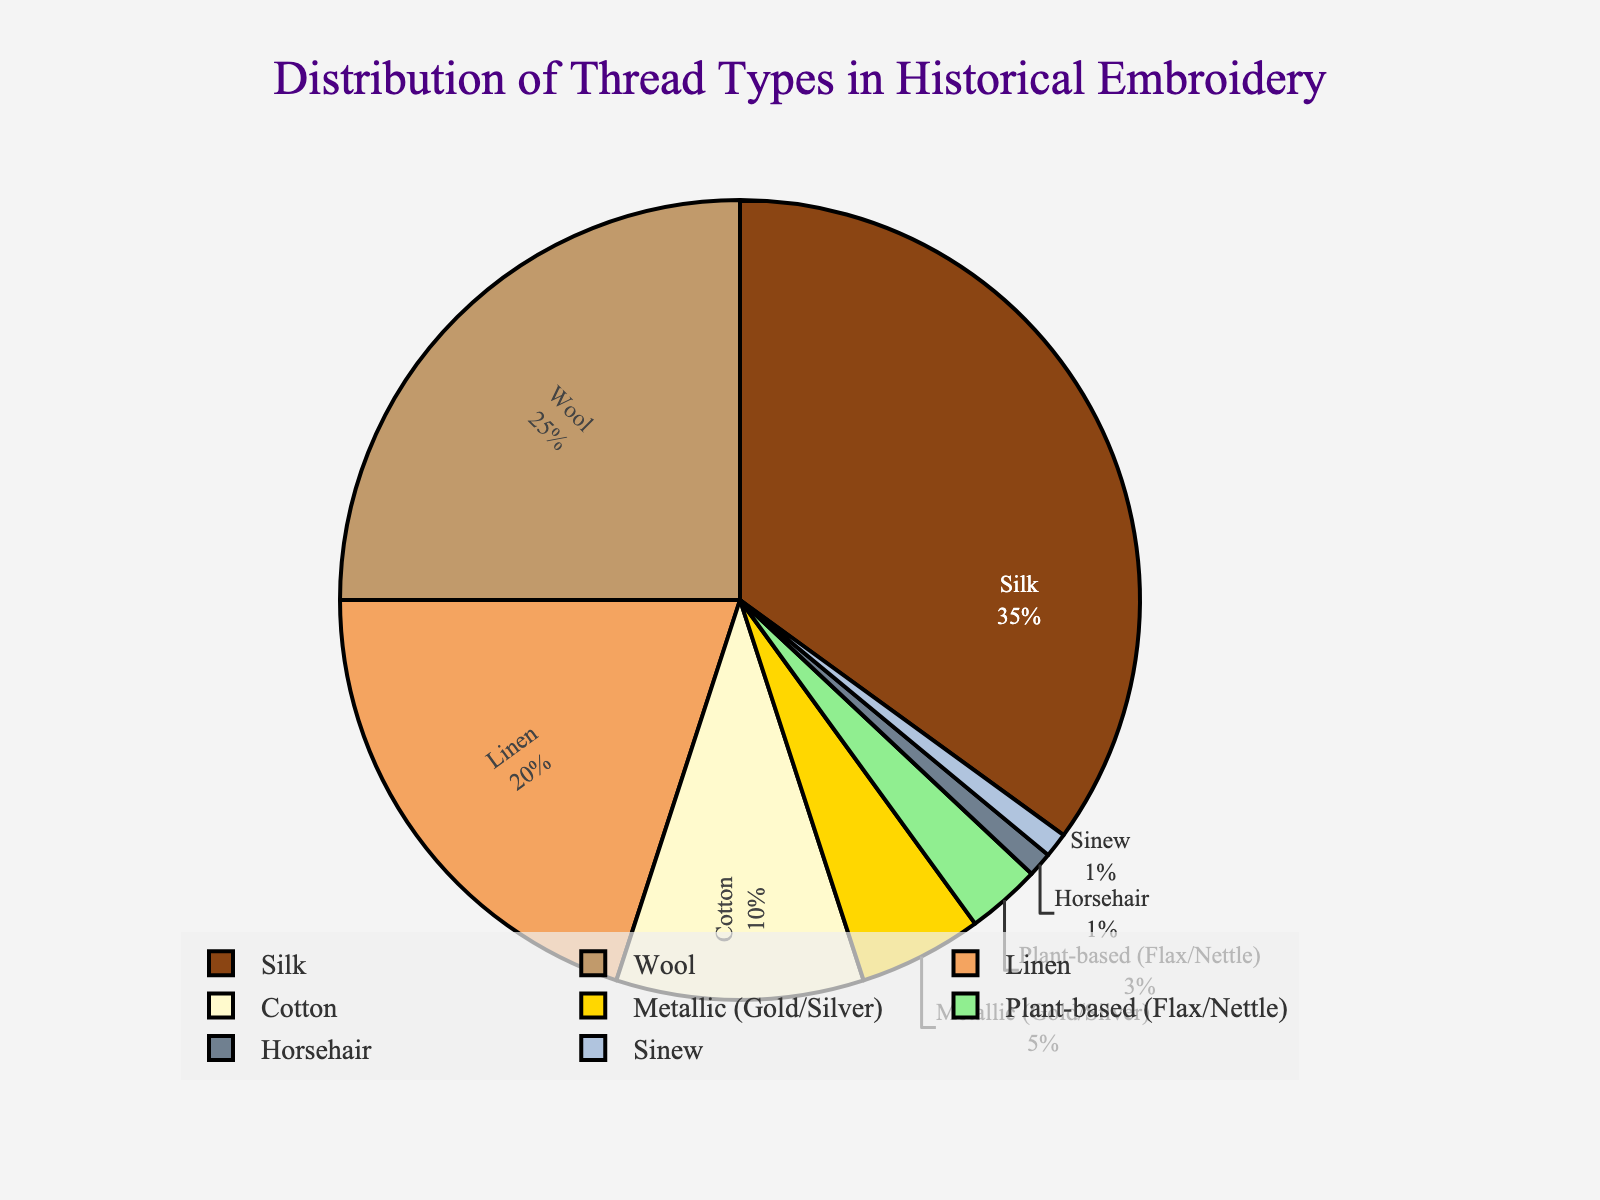What is the largest segment in the pie chart? The largest segment in the pie chart represents the thread type with the highest percentage. By visually identifying the largest area of the pie chart, we can see that Silk is the most represented thread type at 35%.
Answer: Silk Which thread type has the lowest percentage? The smallest segment in the pie chart indicates the thread type with the lowest percentage. By visually inspecting the chart, Horsehair and Sinew each occupy the smallest area, both with a percentage of 1%.
Answer: Horsehair and Sinew How much more percentage does Silk hold compared to Cotton? To find the difference, we subtract the percentage of Cotton from that of Silk. Silk has 35% and Cotton has 10%, so the difference is 35% - 10% = 25%.
Answer: 25% What is the combined percentage of Wool, Linen, and Cotton? To find the combined percentage, sum the individual percentages of Wool, Linen, and Cotton. Wool is 25%, Linen is 20%, and Cotton is 10%. So the combined percentage is 25% + 20% + 10% = 55%.
Answer: 55% Which segments are visually highlighted with a metallic color? The pie chart uses distinct colors for different thread types. The segment highlighted with a metallic color represents Metallic (Gold/Silver).
Answer: Metallic (Gold/Silver) Is the percentage of Linen greater than that of Metallic (Gold/Silver)? By comparing the percentages, Linen has 20% and Metallic (Gold/Silver) has 5%. Since 20% is greater than 5%, the answer is yes.
Answer: Yes How many thread types have a percentage less than 10%? Visually identify and count the segments with percentages less than 10%. The thread types are Metallic (Gold/Silver) at 5%, Plant-based (Flax/Nettle) at 3%, Horsehair at 1%, and Sinew at 1%, making a total of 4 thread types.
Answer: 4 What is the difference in percentage between the total of Silk and Wool versus the total of Cotton and Linen? Calculate the sum of Silk and Wool, which is 35% + 25% = 60%, and then the sum of Cotton and Linen, which is 10% + 20% = 30%. The difference is 60% - 30% = 30%.
Answer: 30% What is the percentage of non-animal-based threads combined? The non-animal-based threads are Silk, Linen, Cotton, Metallic (Gold/Silver), and Plant-based (Flax/Nettle). Sum their percentages: 35% + 20% + 10% + 5% + 3% = 73%.
Answer: 73% Are there more natural or synthetic threads showing in this pie chart? By inspecting the data, we identify natural threads (Silk, Wool, Linen, Cotton, Plant-based (Flax/Nettle), Horsehair, and Sinew) and a synthetic thread (Metallic). Summing natural threads: 35% + 25% + 20% + 10% + 3% + 1% + 1% = 95%. Since 95% is greater than the synthetic's 5%, there are more natural threads.
Answer: Natural 